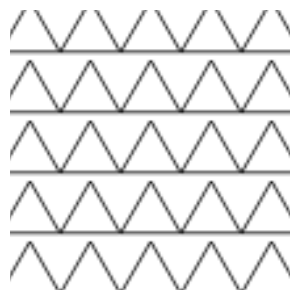In the geometric pattern shown above, what is the total number of complete triangles visible within the rectangular frame? To determine the number of complete triangles in the pattern, we'll follow these steps:

1. Identify the dimensions of the rectangular frame:
   The frame is 280 units wide and 280 units tall.

2. Determine the size of each repeating unit:
   Each triangular unit is 60 units wide and 60 units tall.

3. Calculate the number of complete units that fit horizontally:
   $\frac{280}{60} = 4.\overline{6}$ (4 complete units with remainder)

4. Calculate the number of complete units that fit vertically:
   $\frac{280}{60} = 4.\overline{6}$ (4 complete units with remainder)

5. Multiply the number of complete horizontal and vertical units:
   $4 \times 4 = 16$

6. Count the number of complete triangles in each unit:
   Each 60x60 unit contains 1 complete triangle.

7. Calculate the total number of complete triangles:
   $16 \times 1 = 16$

Therefore, there are 16 complete triangles visible within the rectangular frame.
Answer: 16 